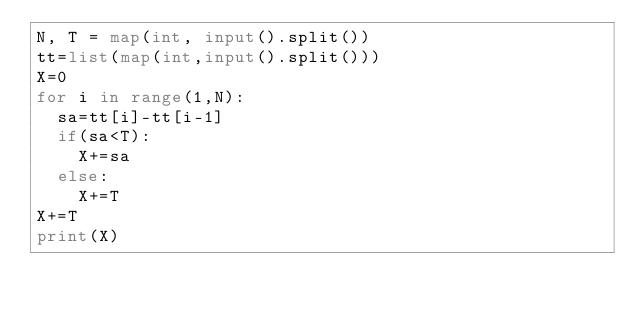<code> <loc_0><loc_0><loc_500><loc_500><_Python_>N, T = map(int, input().split())
tt=list(map(int,input().split()))
X=0
for i in range(1,N):
  sa=tt[i]-tt[i-1]
  if(sa<T):
    X+=sa
  else:
    X+=T
X+=T
print(X)</code> 